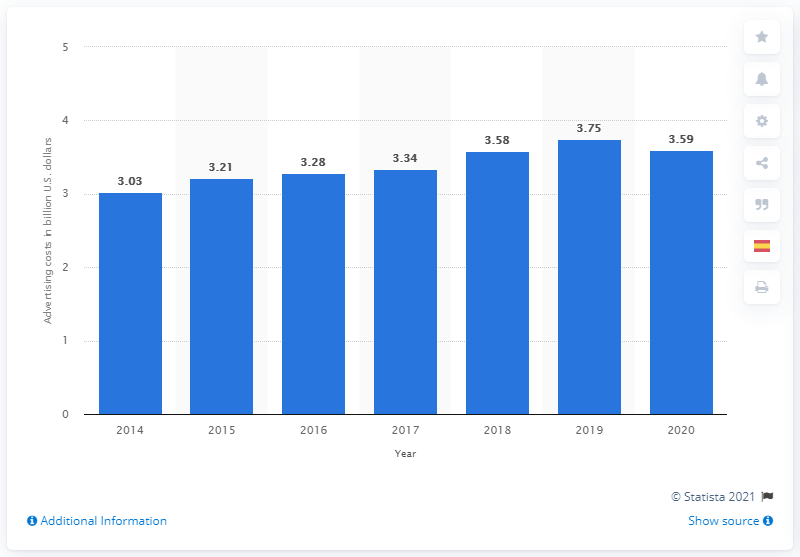Mention a couple of crucial points in this snapshot. Nike spent approximately 3.59 billion dollars on advertising and promotion in 2020. 